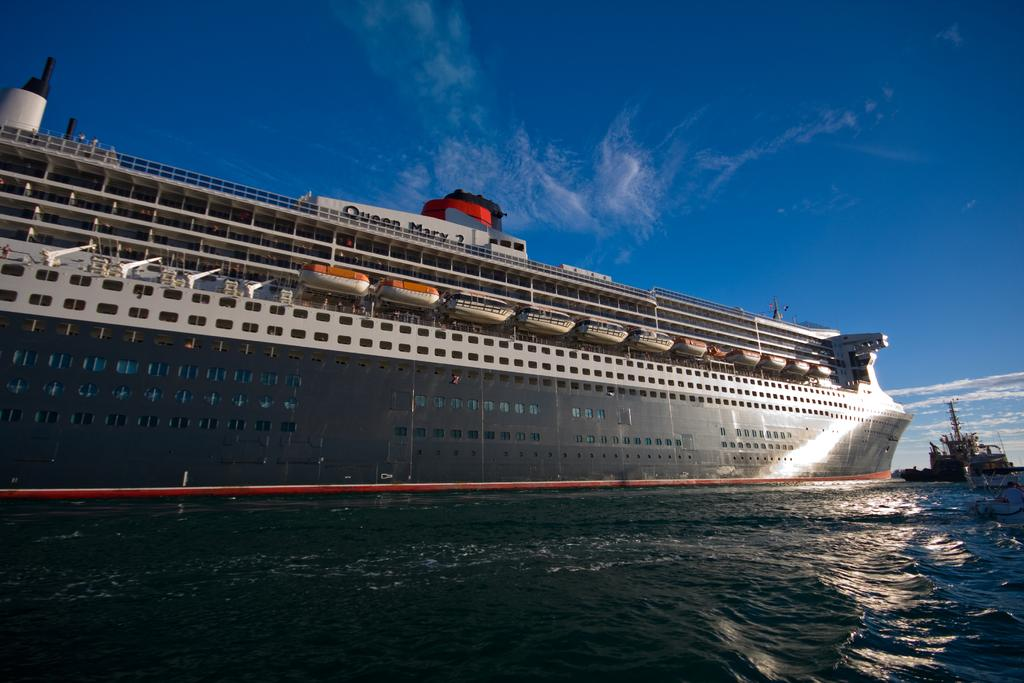What is the main subject in the center of the image? There is a ship in the center of the image. Are there any other ships visible in the image? Yes, there is another ship at the right side of the image. What type of environment is depicted in the image? The image shows water at the bottom and the sky at the top, suggesting a maritime setting. How many ships can be seen in the image? There are two ships visible in the image. Can you observe any bricks on the ship in the image? There are no bricks visible on the ship in the image. How does the ship fly in the image? Ships do not fly; they sail on water. The ship in the image is sailing on the water visible at the bottom of the image. 